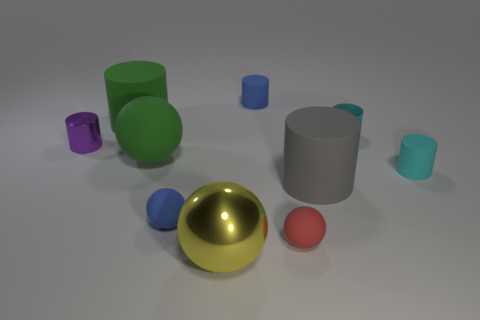There is a small thing that is left of the yellow metal ball and in front of the gray cylinder; what material is it made of?
Provide a short and direct response. Rubber. Are there an equal number of metal objects behind the small purple cylinder and large yellow metallic things?
Ensure brevity in your answer.  Yes. What number of tiny red things are the same shape as the yellow metallic object?
Offer a very short reply. 1. There is a thing in front of the tiny sphere that is to the right of the tiny blue rubber thing behind the purple thing; what size is it?
Your answer should be very brief. Large. Is the material of the large ball that is behind the red rubber thing the same as the purple cylinder?
Your answer should be compact. No. Are there the same number of green cylinders to the right of the big green cylinder and large yellow balls that are behind the metallic sphere?
Ensure brevity in your answer.  Yes. Is there anything else that is the same size as the gray matte object?
Ensure brevity in your answer.  Yes. There is a big green object that is the same shape as the large yellow thing; what is its material?
Your response must be concise. Rubber. Are there any tiny red things that are behind the blue sphere to the right of the big green matte thing that is in front of the tiny purple cylinder?
Give a very brief answer. No. Does the thing in front of the tiny red matte ball have the same shape as the tiny blue matte object that is in front of the cyan matte thing?
Your response must be concise. Yes. 